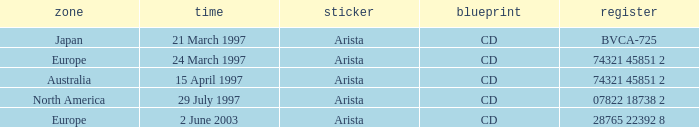What's the Date with the Region of Europe and has a Catalog of 28765 22392 8? 2 June 2003. 